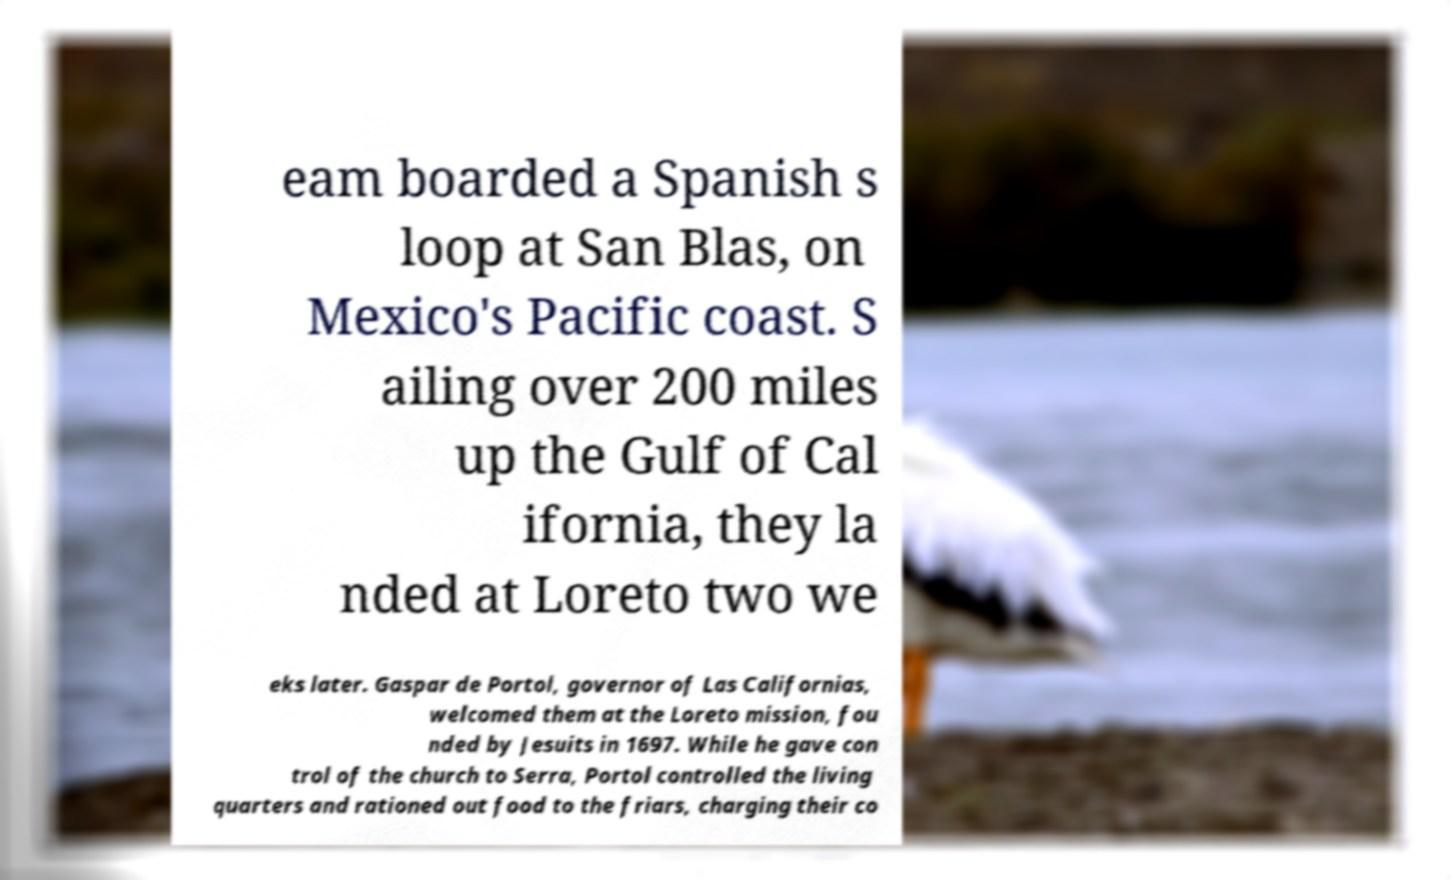Can you read and provide the text displayed in the image?This photo seems to have some interesting text. Can you extract and type it out for me? eam boarded a Spanish s loop at San Blas, on Mexico's Pacific coast. S ailing over 200 miles up the Gulf of Cal ifornia, they la nded at Loreto two we eks later. Gaspar de Portol, governor of Las Californias, welcomed them at the Loreto mission, fou nded by Jesuits in 1697. While he gave con trol of the church to Serra, Portol controlled the living quarters and rationed out food to the friars, charging their co 